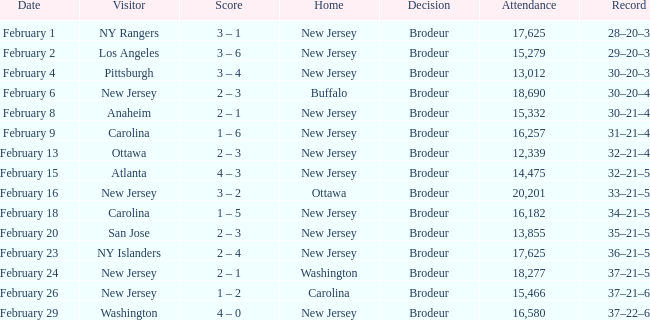What was the score when the NY Islanders was the visiting team? 2 – 4. Give me the full table as a dictionary. {'header': ['Date', 'Visitor', 'Score', 'Home', 'Decision', 'Attendance', 'Record'], 'rows': [['February 1', 'NY Rangers', '3 – 1', 'New Jersey', 'Brodeur', '17,625', '28–20–3'], ['February 2', 'Los Angeles', '3 – 6', 'New Jersey', 'Brodeur', '15,279', '29–20–3'], ['February 4', 'Pittsburgh', '3 – 4', 'New Jersey', 'Brodeur', '13,012', '30–20–3'], ['February 6', 'New Jersey', '2 – 3', 'Buffalo', 'Brodeur', '18,690', '30–20–4'], ['February 8', 'Anaheim', '2 – 1', 'New Jersey', 'Brodeur', '15,332', '30–21–4'], ['February 9', 'Carolina', '1 – 6', 'New Jersey', 'Brodeur', '16,257', '31–21–4'], ['February 13', 'Ottawa', '2 – 3', 'New Jersey', 'Brodeur', '12,339', '32–21–4'], ['February 15', 'Atlanta', '4 – 3', 'New Jersey', 'Brodeur', '14,475', '32–21–5'], ['February 16', 'New Jersey', '3 – 2', 'Ottawa', 'Brodeur', '20,201', '33–21–5'], ['February 18', 'Carolina', '1 – 5', 'New Jersey', 'Brodeur', '16,182', '34–21–5'], ['February 20', 'San Jose', '2 – 3', 'New Jersey', 'Brodeur', '13,855', '35–21–5'], ['February 23', 'NY Islanders', '2 – 4', 'New Jersey', 'Brodeur', '17,625', '36–21–5'], ['February 24', 'New Jersey', '2 – 1', 'Washington', 'Brodeur', '18,277', '37–21–5'], ['February 26', 'New Jersey', '1 – 2', 'Carolina', 'Brodeur', '15,466', '37–21–6'], ['February 29', 'Washington', '4 – 0', 'New Jersey', 'Brodeur', '16,580', '37–22–6']]} 